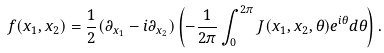Convert formula to latex. <formula><loc_0><loc_0><loc_500><loc_500>f ( x _ { 1 } , x _ { 2 } ) = \frac { 1 } { 2 } ( \partial _ { x _ { 1 } } - i \partial _ { x _ { 2 } } ) \left ( - \frac { 1 } { 2 \pi } \int _ { 0 } ^ { 2 \pi } J ( x _ { 1 } , x _ { 2 } , \theta ) e ^ { i \theta } d \theta \right ) .</formula> 